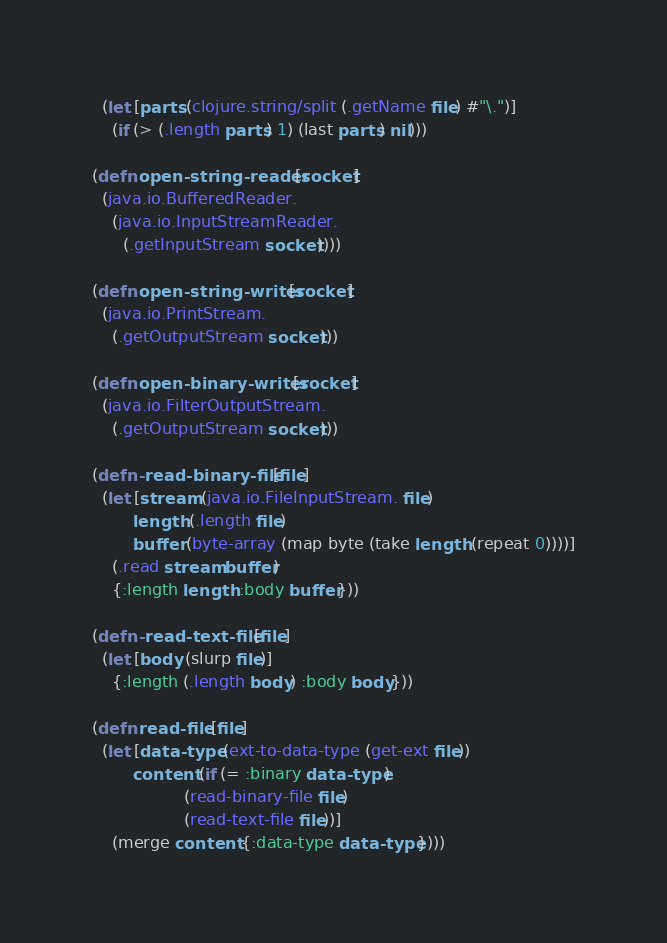<code> <loc_0><loc_0><loc_500><loc_500><_Clojure_>  (let [parts (clojure.string/split (.getName file) #"\.")]
    (if (> (.length parts) 1) (last parts) nil)))

(defn open-string-reader [socket]
  (java.io.BufferedReader. 
    (java.io.InputStreamReader.
      (.getInputStream socket))))

(defn open-string-writer [socket]
  (java.io.PrintStream.
    (.getOutputStream socket)))

(defn open-binary-writer [socket]
  (java.io.FilterOutputStream.
    (.getOutputStream socket)))

(defn- read-binary-file [file]
  (let [stream (java.io.FileInputStream. file)
        length (.length file)
        buffer (byte-array (map byte (take length (repeat 0))))]
    (.read stream buffer)
    {:length length :body buffer}))

(defn- read-text-file [file]
  (let [body (slurp file)]
    {:length (.length body) :body body}))

(defn read-file [file]
  (let [data-type (ext-to-data-type (get-ext file))
        content (if (= :binary data-type)
                  (read-binary-file file)
                  (read-text-file file))]
    (merge content {:data-type data-type})))
</code> 